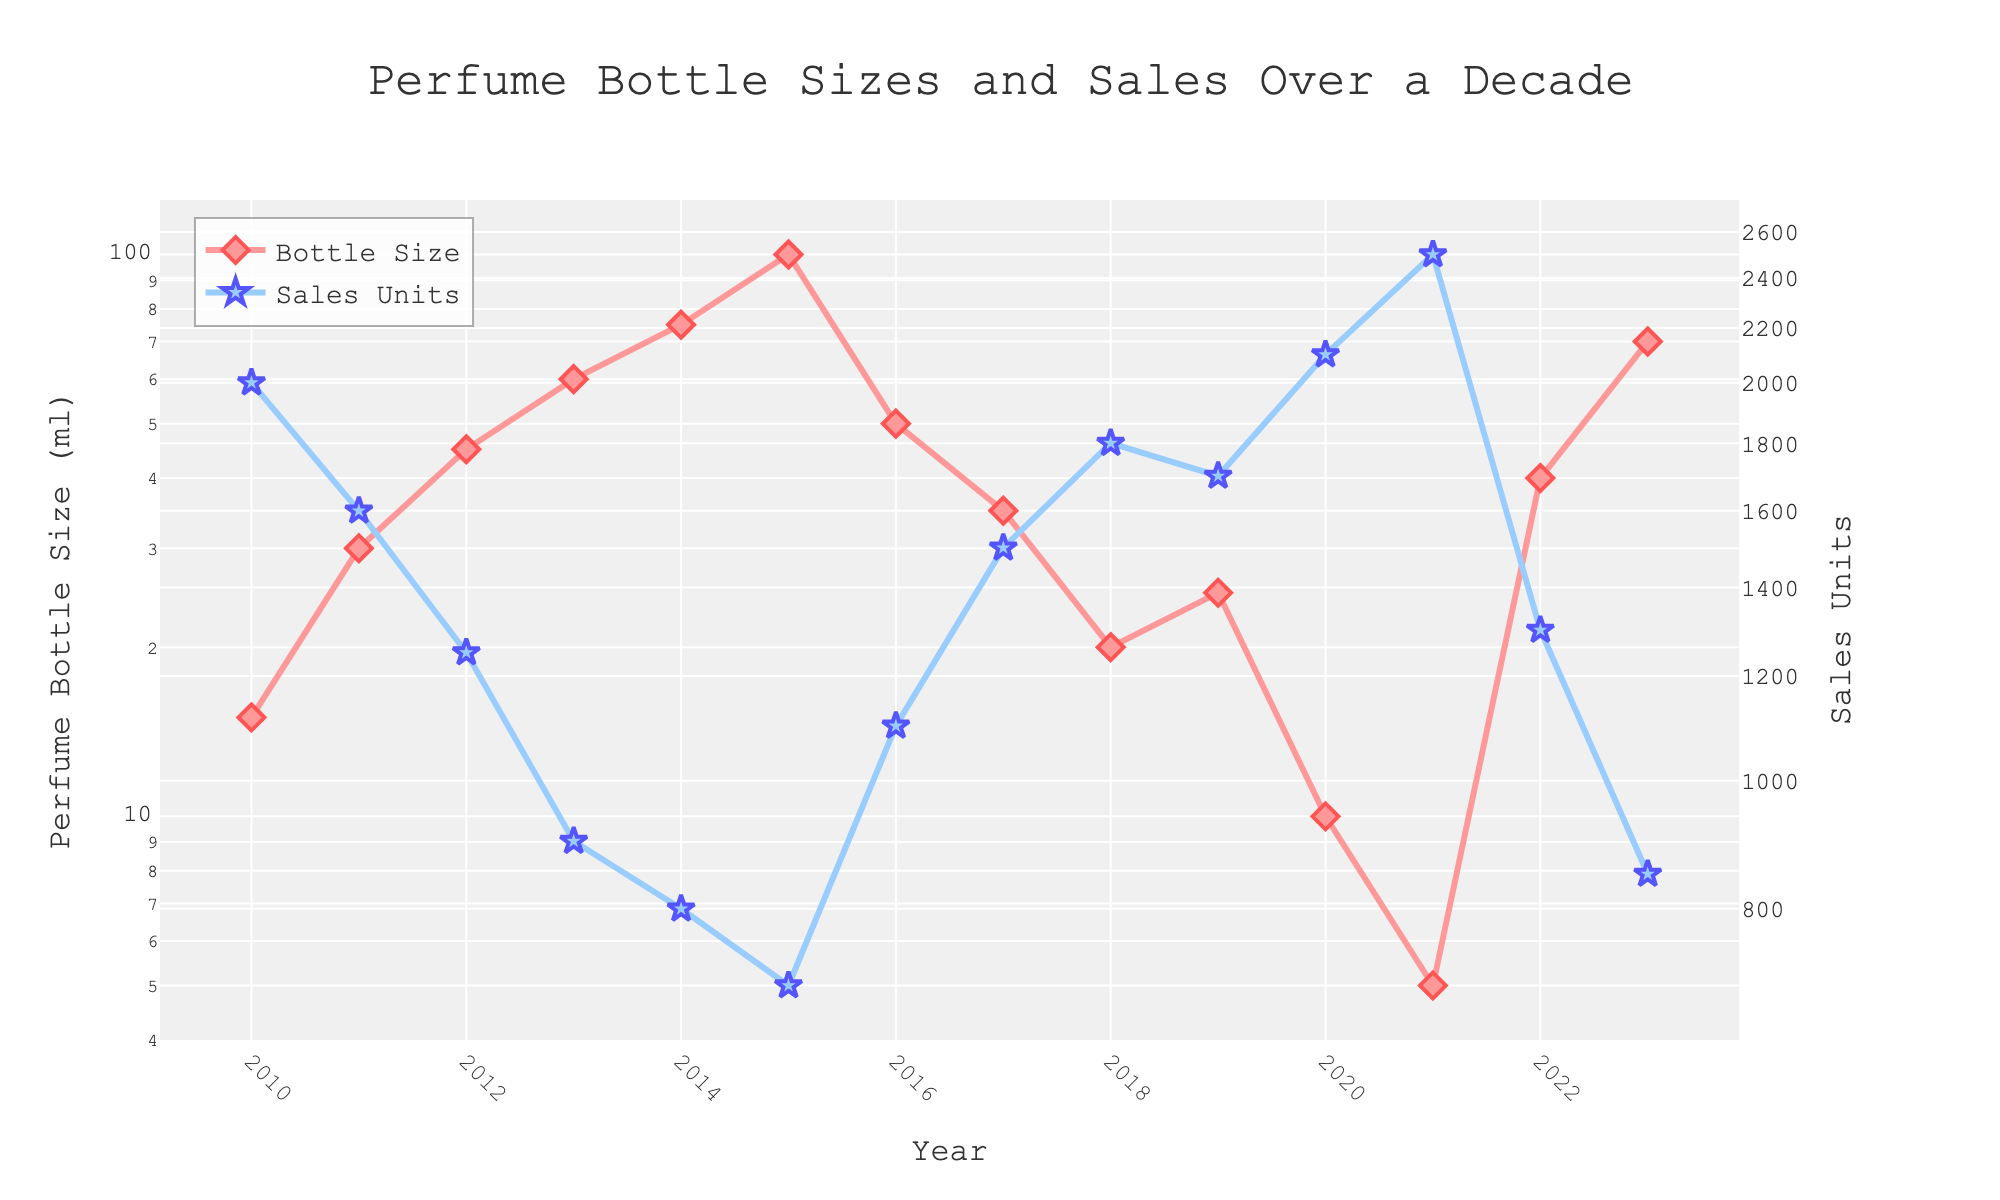What is the title of the figure? The title is displayed at the top center of the plot. It states the main subject of the figure.
Answer: Perfume Bottle Sizes and Sales Over a Decade How many data points are shown for Perfume Bottle Size? Each year from 2010 to 2023 has one corresponding data point for Perfume Bottle Size. Count the markers in the 'Bottle Size' series.
Answer: 14 Which year had the highest sales units? Look at the 'Sales Units' markers and find the one that is highest, then check its corresponding year on the x-axis.
Answer: 2021 In which year were the bottle sizes smallest and what was the corresponding sales unit? Find the data point with the smallest value in the 'Bottle Size' series and then find its corresponding sales unit.
Answer: 2021, 2500 What is the overall trend in perfume bottle sizes over the decade? Observe the general direction of the 'Bottle Size' series from 2010 to 2023.
Answer: Decreasing During which year did the sales units decrease the most compared to the previous year? Calculate the difference in sales for each year and identify the year with the largest drop. **Detailed Explanation**: Compare sales sequentially: (2011: 1600 - 2000), (2012: 1250 - 1600), (2013: 900 - 1250), etc. Identify the largest negative difference.
Answer: 2013 Compare the sales units between 2010 and 2023. Which year had more sales units and by how much? Retrieve the sales units for 2010 and 2023, then subtract the smaller from the larger value. **Detailed Explanation**: Sales in 2010 is 2000, and in 2023 is 850. Difference: 2000 - 850.
Answer: 2010, 1150 units In which year did the perfume bottle size experience a significant increase, and was there a corresponding change in sales units? Identify the year with a notable increase in bottle size and check if there's an associated change in sales units for that year. **Detailed Explanation**: Analyzing bottle sizes annually: 2010(15), 2011(30), 2012(45), etc., notice significant increase 2014(75) from 2013(60). Check sales: 2013(900) vs 2014(800).
Answer: 2014, Yes, sales slightly decrease If the average bottle size from 2010 to 2013 is calculated, what is it? Sum the bottle sizes from 2010 to 2013 and divide by the number of years. **Detailed Explanation**: Sum sizes: 15 + 30 + 45 + 60 = 150. Average: 150/4.
Answer: 37.5 ml Do smaller bottle sizes generally correspond to higher sales units? Observe the relationship between bottle sizes and sales units throughout the plot.
Answer: Yes 